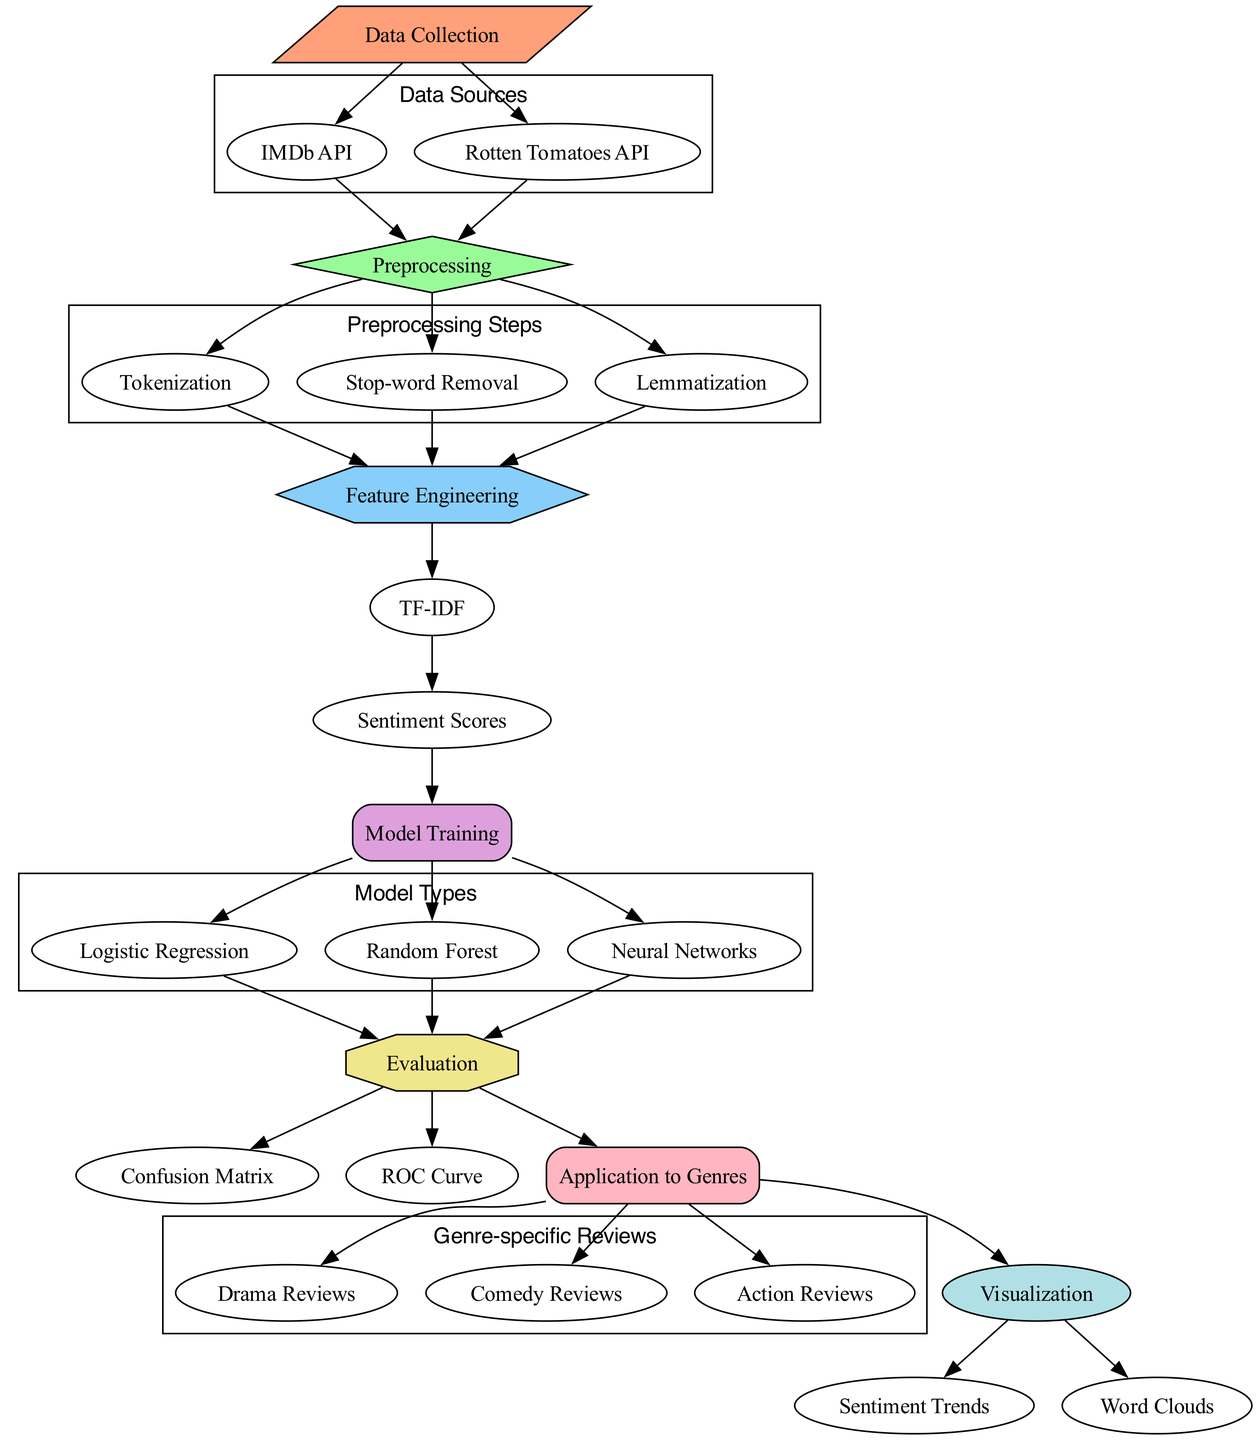What are the data sources in this diagram? The diagram includes two data sources: the IMDb API and the Rotten Tomatoes API, which are shown as nodes connected to the Data Collection node.
Answer: IMDb API, Rotten Tomatoes API How many preprocessing steps are there? The diagram shows three preprocessing steps: Tokenization, Stop-word Removal, and Lemmatization. These nodes are grouped under the Preprocessing node, indicating they are all part of the preprocessing phase.
Answer: Three What follows after Feature Engineering? The next step after Feature Engineering is the TF-IDF node, indicating that TF-IDF is applied to the features that have been engineered from the reviews.
Answer: TF-IDF Which models are trained in this diagram? The diagram lists three models: Logistic Regression, Random Forest, and Neural Networks. These are all connected to the Model Training node, showing they are the types of models used for training.
Answer: Logistic Regression, Random Forest, Neural Networks How many types of genre-specific reviews are applied? There are three types of genre-specific reviews shown in the Application node: Drama Reviews, Comedy Reviews, and Action Reviews, indicating the analysis is applied across these genres.
Answer: Three Which evaluation metrics are presented in the diagram? The evaluation metrics highlighted in the diagram are the Confusion Matrix and the ROC Curve, both connected to the Evaluation node, signifying they are used to assess the model's performance.
Answer: Confusion Matrix, ROC Curve What is the main purpose of the Visualization node? The Visualization node has two outputs: Sentiment Trends and Word Clouds, which indicates that the purpose of visualization is to present the analyzed sentiment in different visual forms for understanding.
Answer: Sentiment Trends, Word Clouds Which node comes first in the analysis process? The first node in the analysis process is Data Collection, as it initiates the flow by gathering data from sources like the IMDb API and Rotten Tomatoes API.
Answer: Data Collection How many nodes are connected to the Evaluation node? The Evaluation node is connected to three other nodes: Confusion Matrix, ROC Curve, and Application, showing that it evaluates the models and their applications.
Answer: Three 